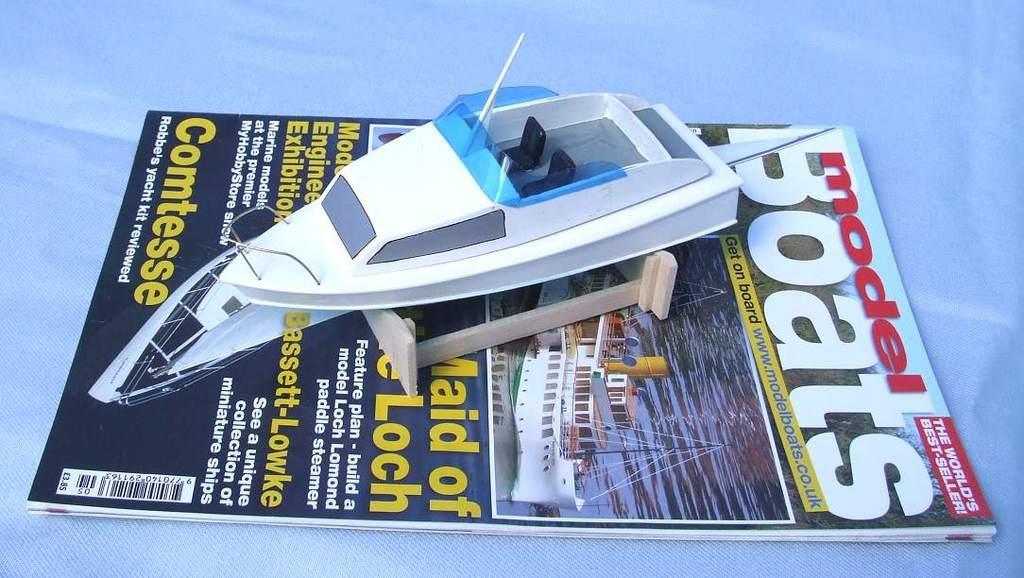How would you summarize this image in a sentence or two? In this image, we can see a book. In the book, we can see a toy ship. In the background, we can see white color. 